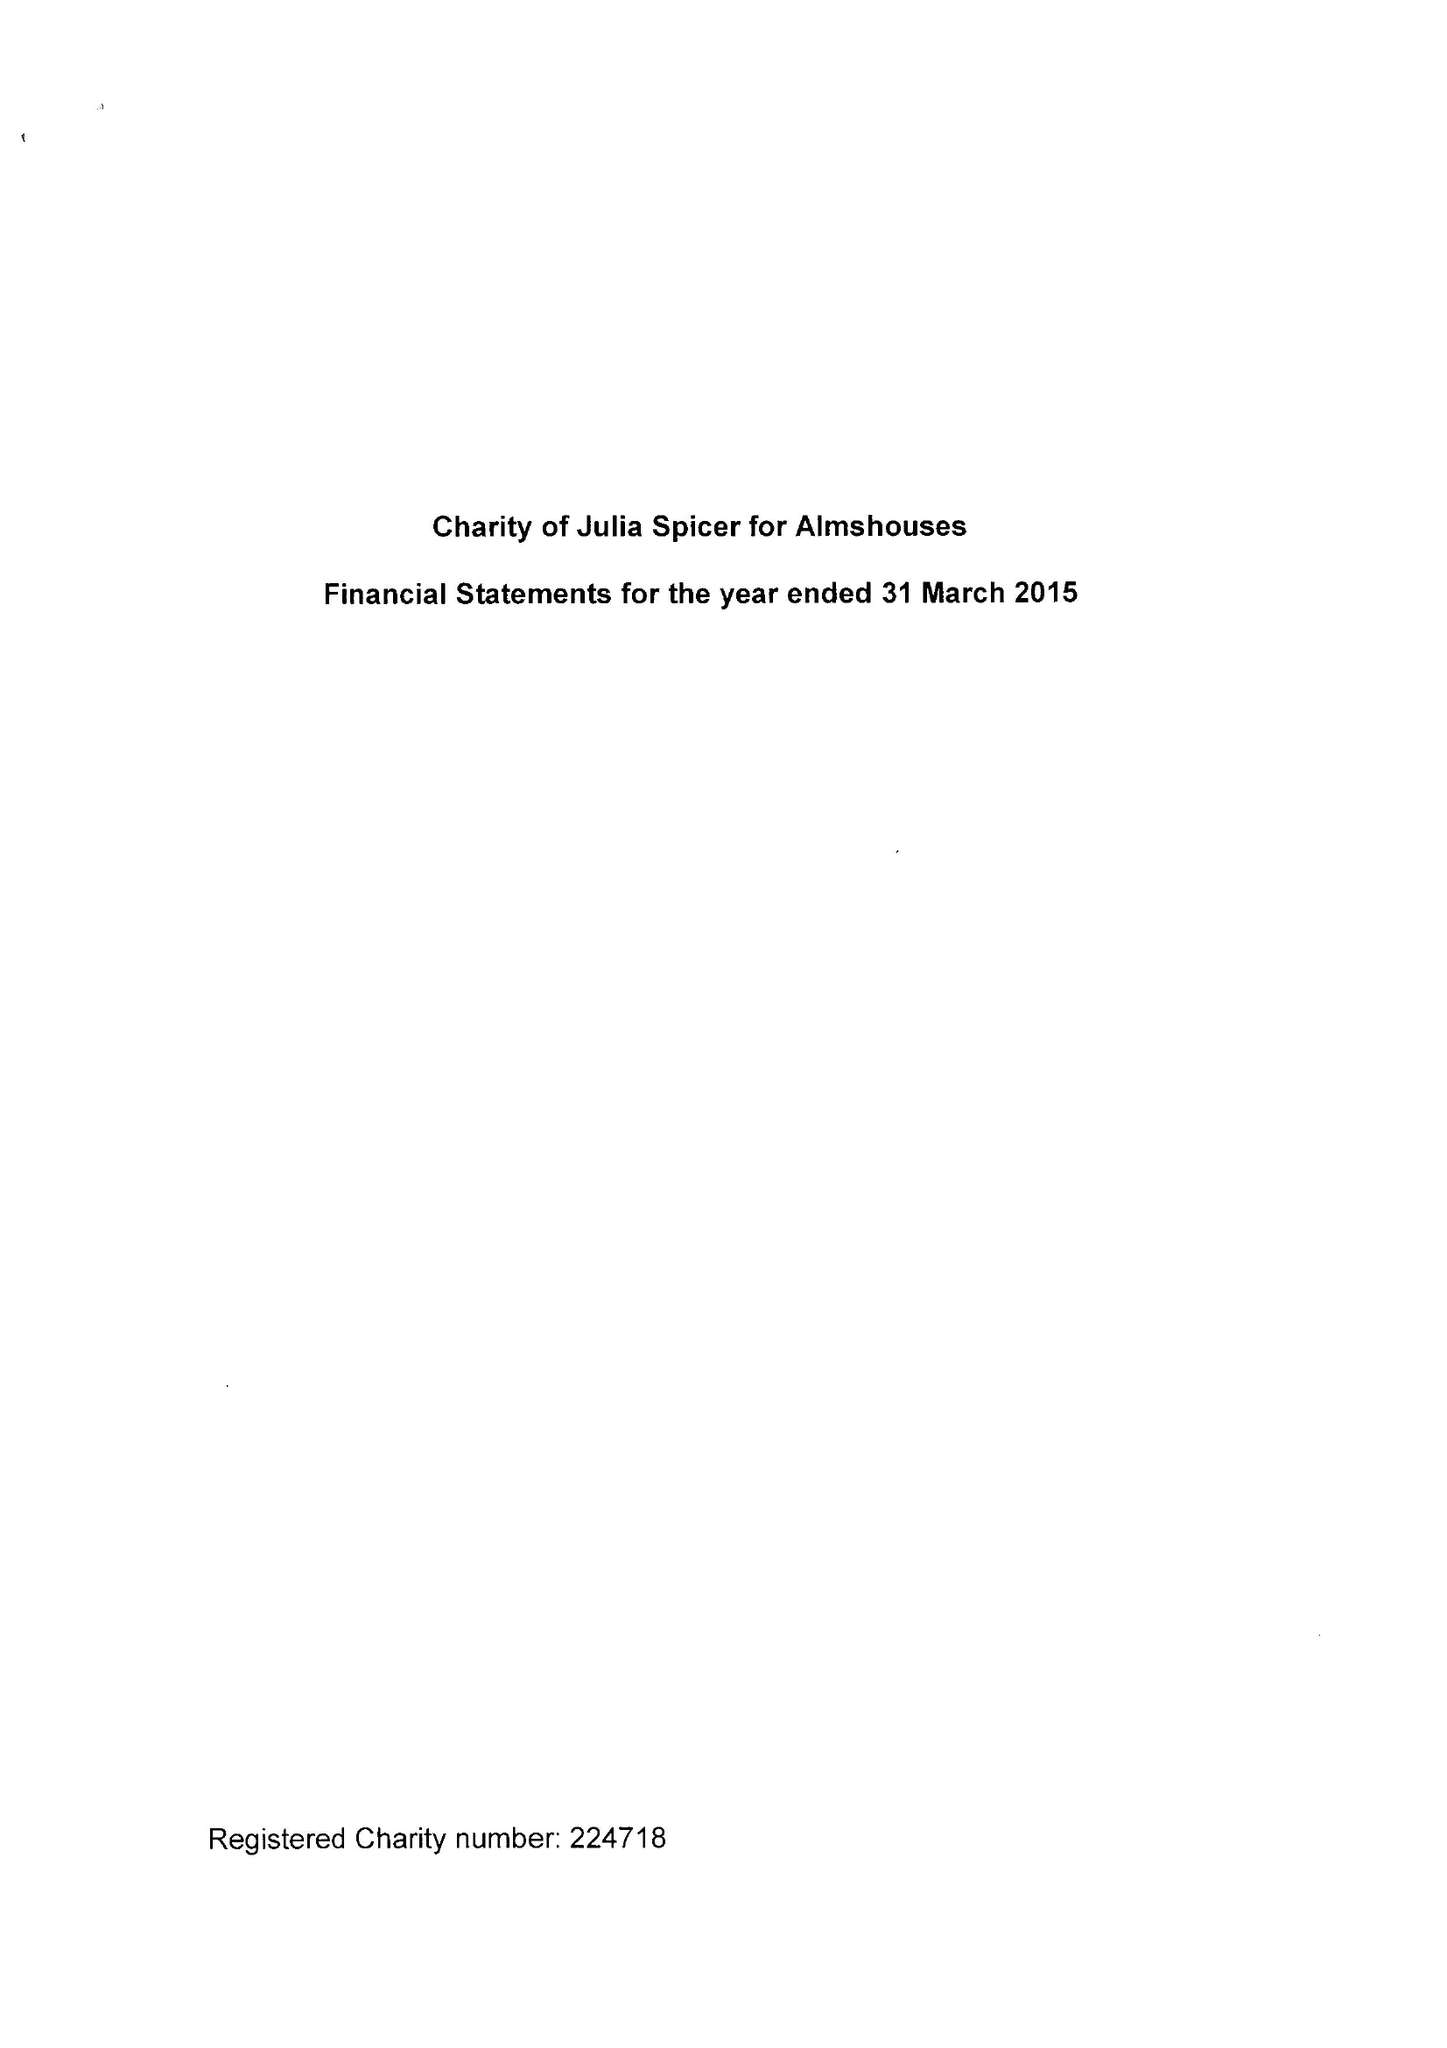What is the value for the spending_annually_in_british_pounds?
Answer the question using a single word or phrase. 30393.00 